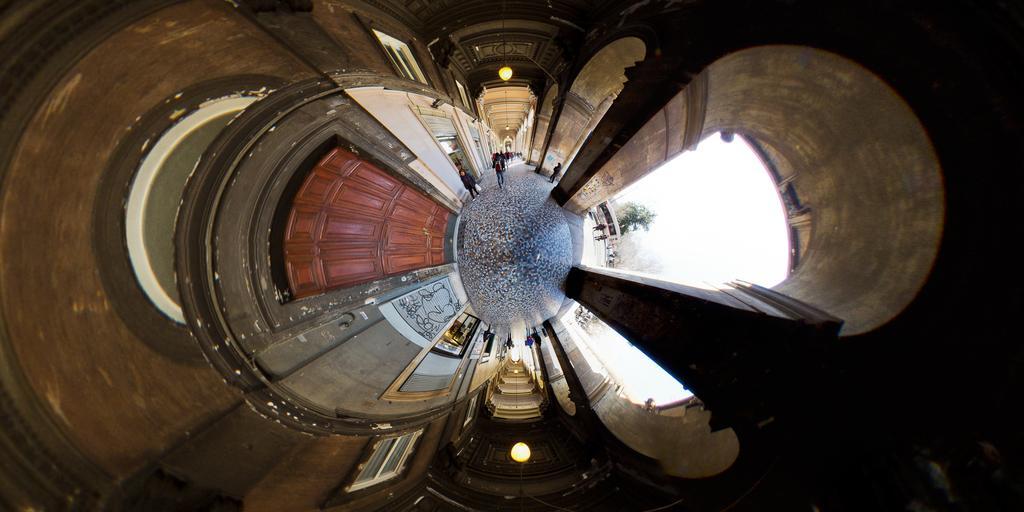Describe this image in one or two sentences. In the middle of the image few people are walking and there is a door and tree and there are some frames. At the top of the image there is roof and light. 